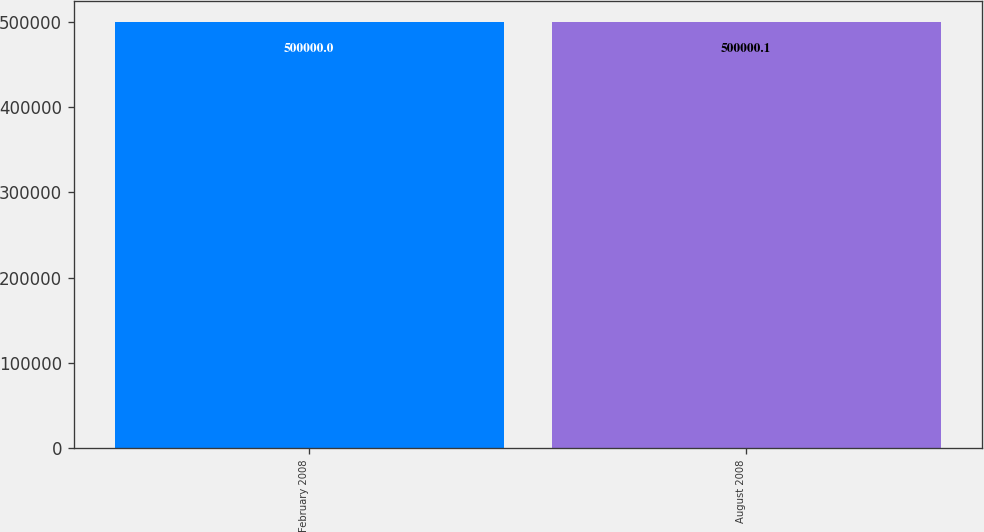<chart> <loc_0><loc_0><loc_500><loc_500><bar_chart><fcel>February 2008<fcel>August 2008<nl><fcel>500000<fcel>500000<nl></chart> 